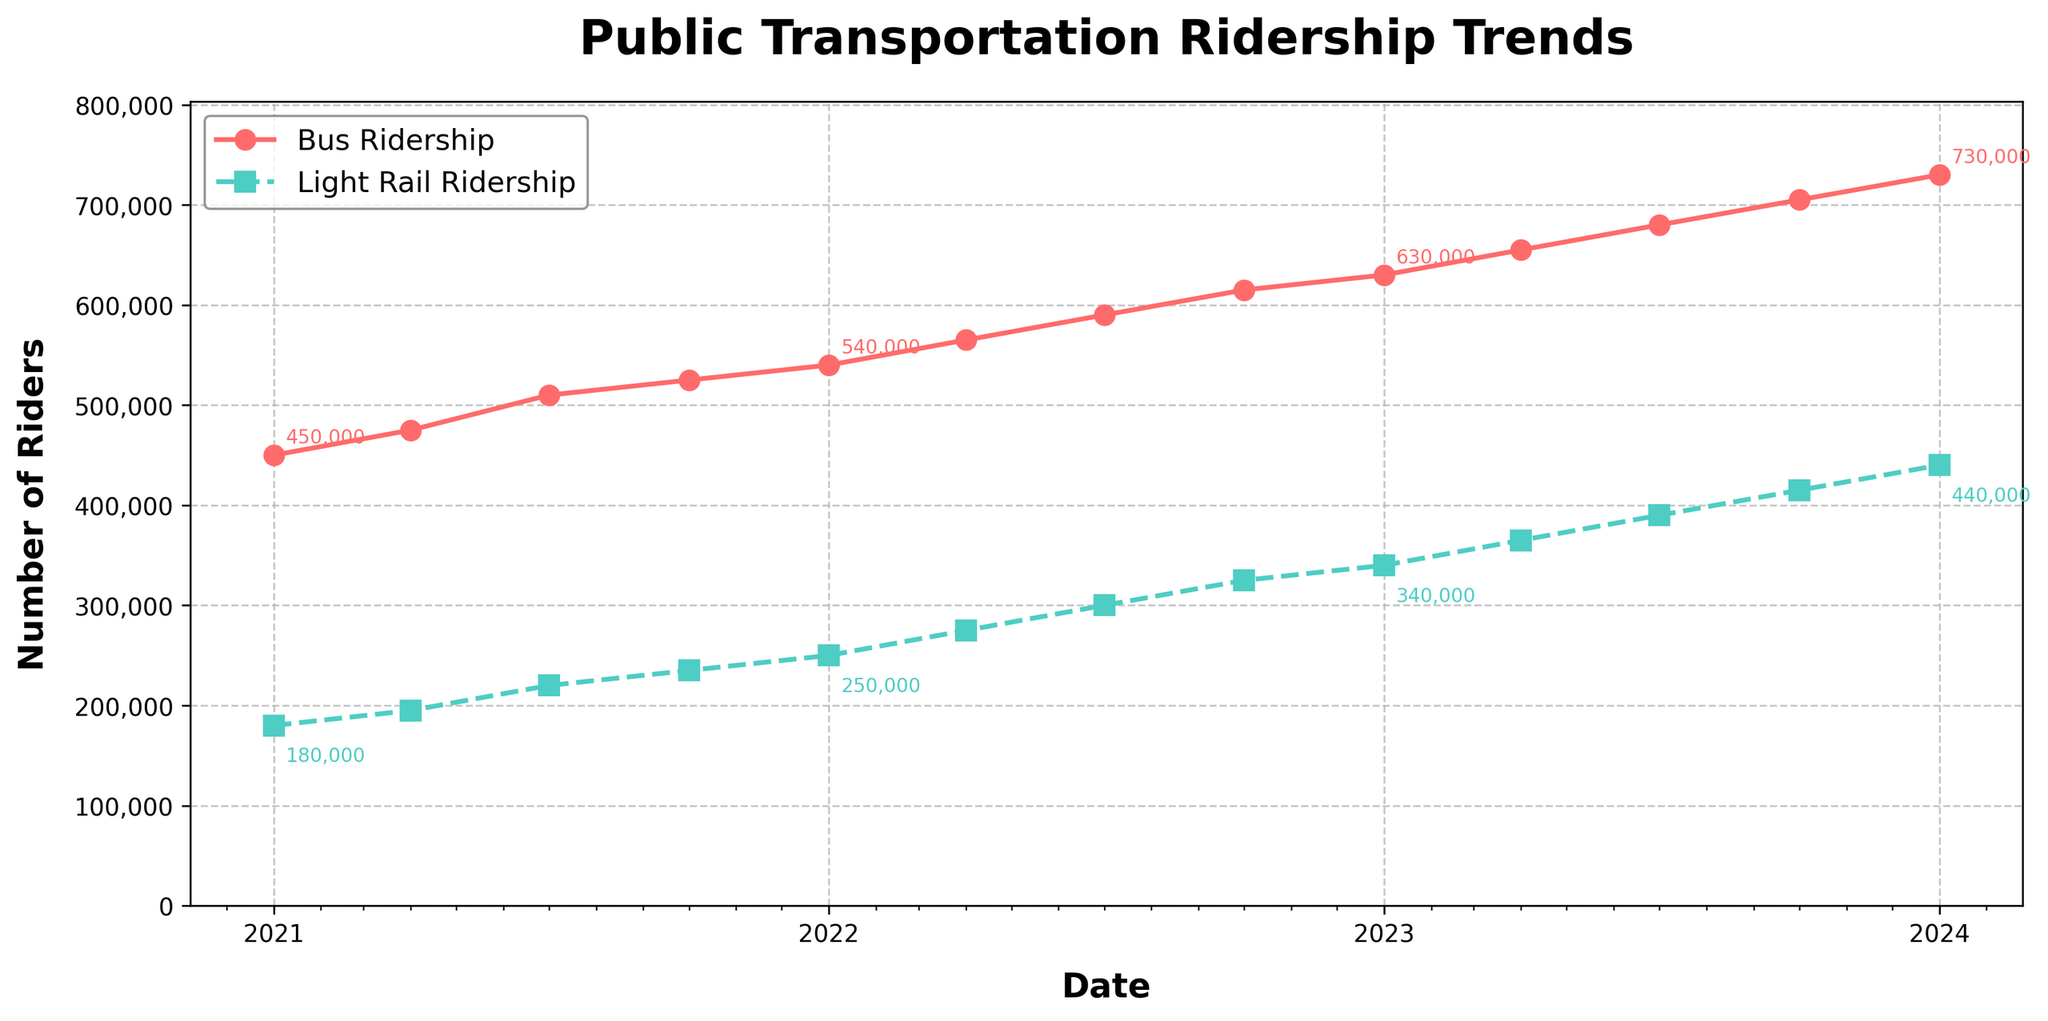What's the total ridership for buses and light rail in April 2023? By adding the bus ridership and light rail ridership in April 2023, we get the total ridership. The bus ridership is 655,000 and light rail ridership is 365,000. Summing these gives 655,000 + 365,000 = 1,020,000.
Answer: 1,020,000 Between which two consecutive months did bus ridership see the highest increase? Comparing the differences between consecutive months, we find that the largest increase in bus ridership occurs between July 2022 (590,000) and October 2022 (615,000). The increase is 615,000 - 590,000 = 25,000, which is the highest among all.
Answer: July 2022 and October 2022 How do light rail ridership numbers in January 2021 compare to July 2023? The light rail ridership in January 2021 is 180,000. In July 2023, it is 390,000. The increase from January 2021 to July 2023 is 390,000 - 180,000 = 210,000. Thus, the ridership in July 2023 is significantly higher than in January 2021.
Answer: Higher Describe the trend of bus ridership from January 2021 to January 2024. The bus ridership shows a steady increase from 450,000 in January 2021 to 730,000 in January 2024, indicating a consistent upward trend over the three-year period.
Answer: Steady increase At what time point did the bus ridership and light rail ridership first surpass 500,000 and 300,000 respectively? The bus ridership first surpassed 500,000 in July 2021 (510,000). The light rail ridership first surpassed 300,000 in July 2022 (300,000).
Answer: July 2021 (bus), July 2022 (light rail) Which mode of transportation had a higher ridership increase percentage from January 2021 to January 2024? Calculating the percentage increase: For buses: (730,000 - 450,000) / 450,000 * 100 = 62.2%. For light rail: (440,000 - 180,000) / 180,000 * 100 = 144.4%. Thus, the light rail had a higher increase percentage.
Answer: Light rail What was the ridership difference between bus and light rail in October 2023? In October 2023, the bus ridership is 705,000, and the light rail ridership is 415,000. The difference is 705,000 - 415,000 = 290,000.
Answer: 290,000 When was the first quarter where both bus and light rail ridership increased compared to the previous quarter? Observing the data, both bus and light rail ridership increased between January 2021 and April 2021, where bus ridership increased from 450,000 to 475,000 and light rail ridership from 180,000 to 195,000.
Answer: April 2021 What colors represent bus and light rail ridership in the chart? In the chart, bus ridership is represented in red, while light rail ridership is shown in green.
Answer: Red (bus), Green (light rail) During which month and year did light rail ridership reach exactly 250,000? Light rail ridership reached 250,000 in January 2022.
Answer: January 2022 